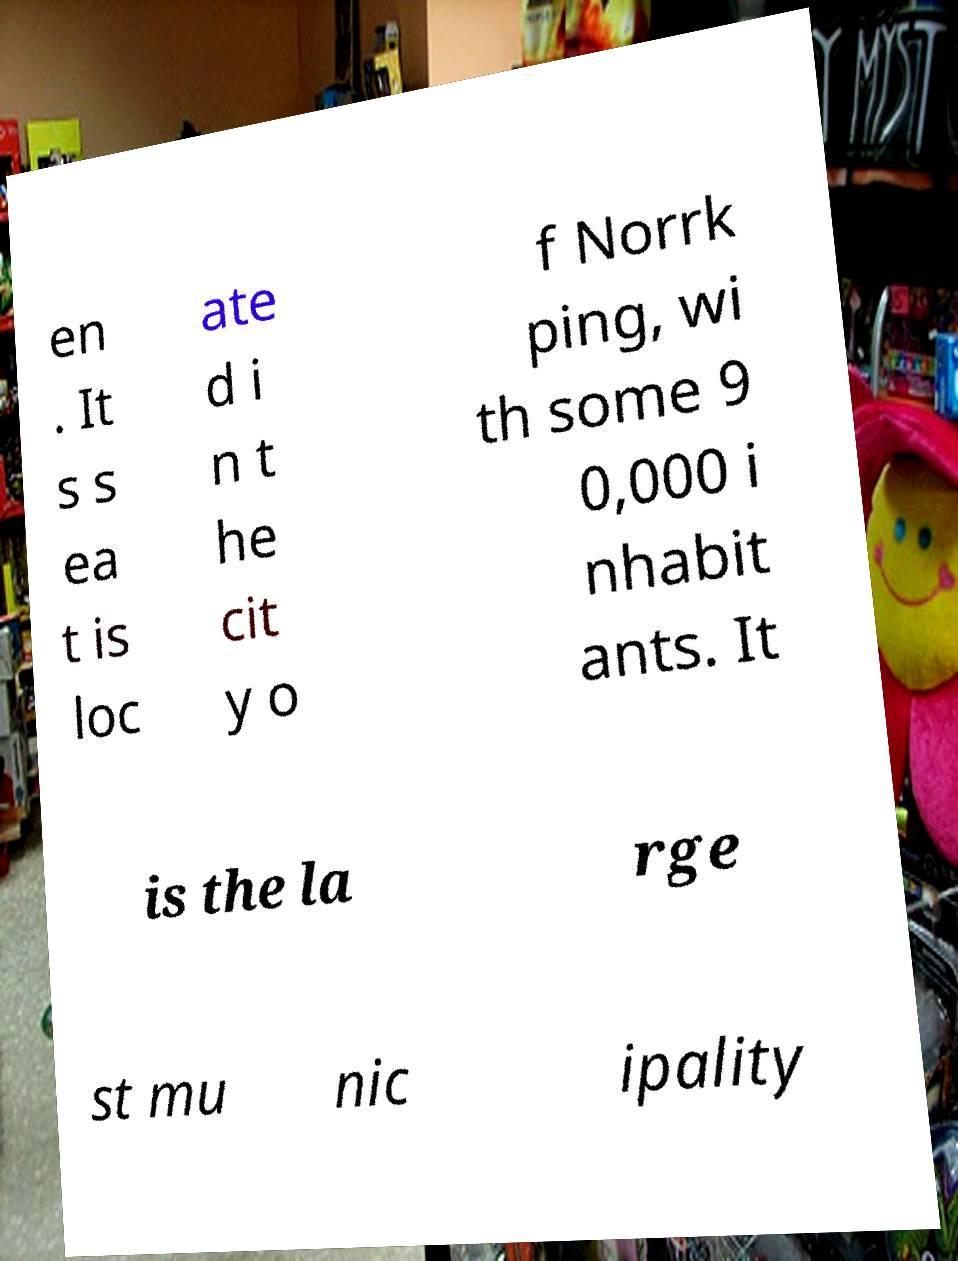Could you assist in decoding the text presented in this image and type it out clearly? en . It s s ea t is loc ate d i n t he cit y o f Norrk ping, wi th some 9 0,000 i nhabit ants. It is the la rge st mu nic ipality 